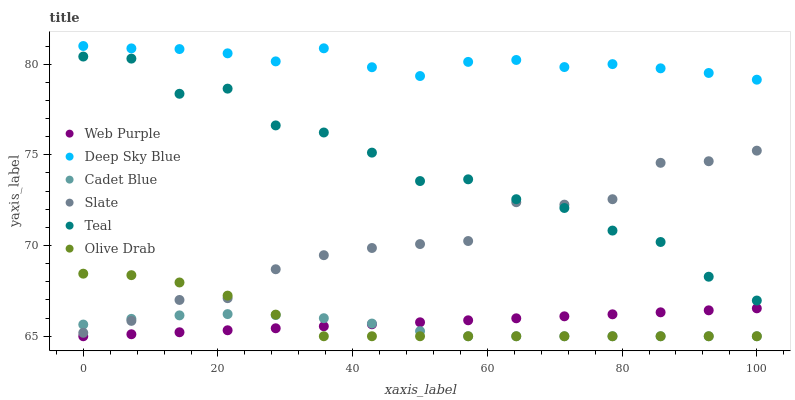Does Cadet Blue have the minimum area under the curve?
Answer yes or no. Yes. Does Deep Sky Blue have the maximum area under the curve?
Answer yes or no. Yes. Does Slate have the minimum area under the curve?
Answer yes or no. No. Does Slate have the maximum area under the curve?
Answer yes or no. No. Is Web Purple the smoothest?
Answer yes or no. Yes. Is Teal the roughest?
Answer yes or no. Yes. Is Deep Sky Blue the smoothest?
Answer yes or no. No. Is Deep Sky Blue the roughest?
Answer yes or no. No. Does Cadet Blue have the lowest value?
Answer yes or no. Yes. Does Slate have the lowest value?
Answer yes or no. No. Does Deep Sky Blue have the highest value?
Answer yes or no. Yes. Does Slate have the highest value?
Answer yes or no. No. Is Web Purple less than Slate?
Answer yes or no. Yes. Is Deep Sky Blue greater than Web Purple?
Answer yes or no. Yes. Does Olive Drab intersect Web Purple?
Answer yes or no. Yes. Is Olive Drab less than Web Purple?
Answer yes or no. No. Is Olive Drab greater than Web Purple?
Answer yes or no. No. Does Web Purple intersect Slate?
Answer yes or no. No. 